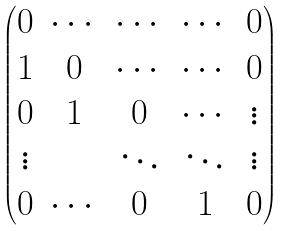Convert formula to latex. <formula><loc_0><loc_0><loc_500><loc_500>\begin{pmatrix} 0 & \cdots & \cdots & \cdots & 0 \\ 1 & 0 & \cdots & \cdots & 0 \\ 0 & 1 & 0 & \cdots & \vdots \\ \vdots & & \ddots & \ddots & \vdots \\ 0 & \cdots & 0 & 1 & 0 \end{pmatrix}</formula> 